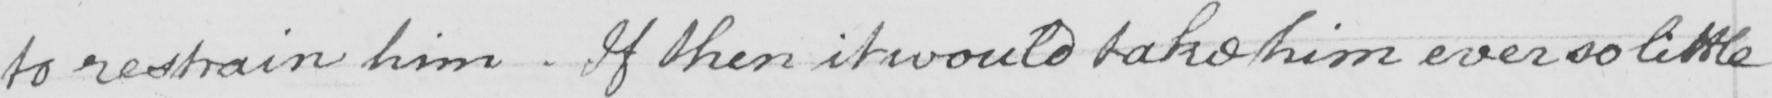What does this handwritten line say? to restrain him . If then it would take him ever so little 